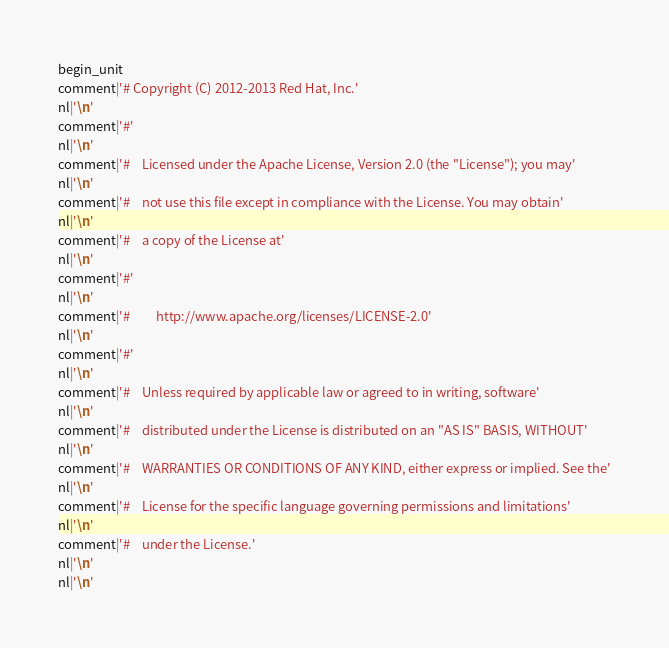Convert code to text. <code><loc_0><loc_0><loc_500><loc_500><_Python_>begin_unit
comment|'# Copyright (C) 2012-2013 Red Hat, Inc.'
nl|'\n'
comment|'#'
nl|'\n'
comment|'#    Licensed under the Apache License, Version 2.0 (the "License"); you may'
nl|'\n'
comment|'#    not use this file except in compliance with the License. You may obtain'
nl|'\n'
comment|'#    a copy of the License at'
nl|'\n'
comment|'#'
nl|'\n'
comment|'#         http://www.apache.org/licenses/LICENSE-2.0'
nl|'\n'
comment|'#'
nl|'\n'
comment|'#    Unless required by applicable law or agreed to in writing, software'
nl|'\n'
comment|'#    distributed under the License is distributed on an "AS IS" BASIS, WITHOUT'
nl|'\n'
comment|'#    WARRANTIES OR CONDITIONS OF ANY KIND, either express or implied. See the'
nl|'\n'
comment|'#    License for the specific language governing permissions and limitations'
nl|'\n'
comment|'#    under the License.'
nl|'\n'
nl|'\n'</code> 